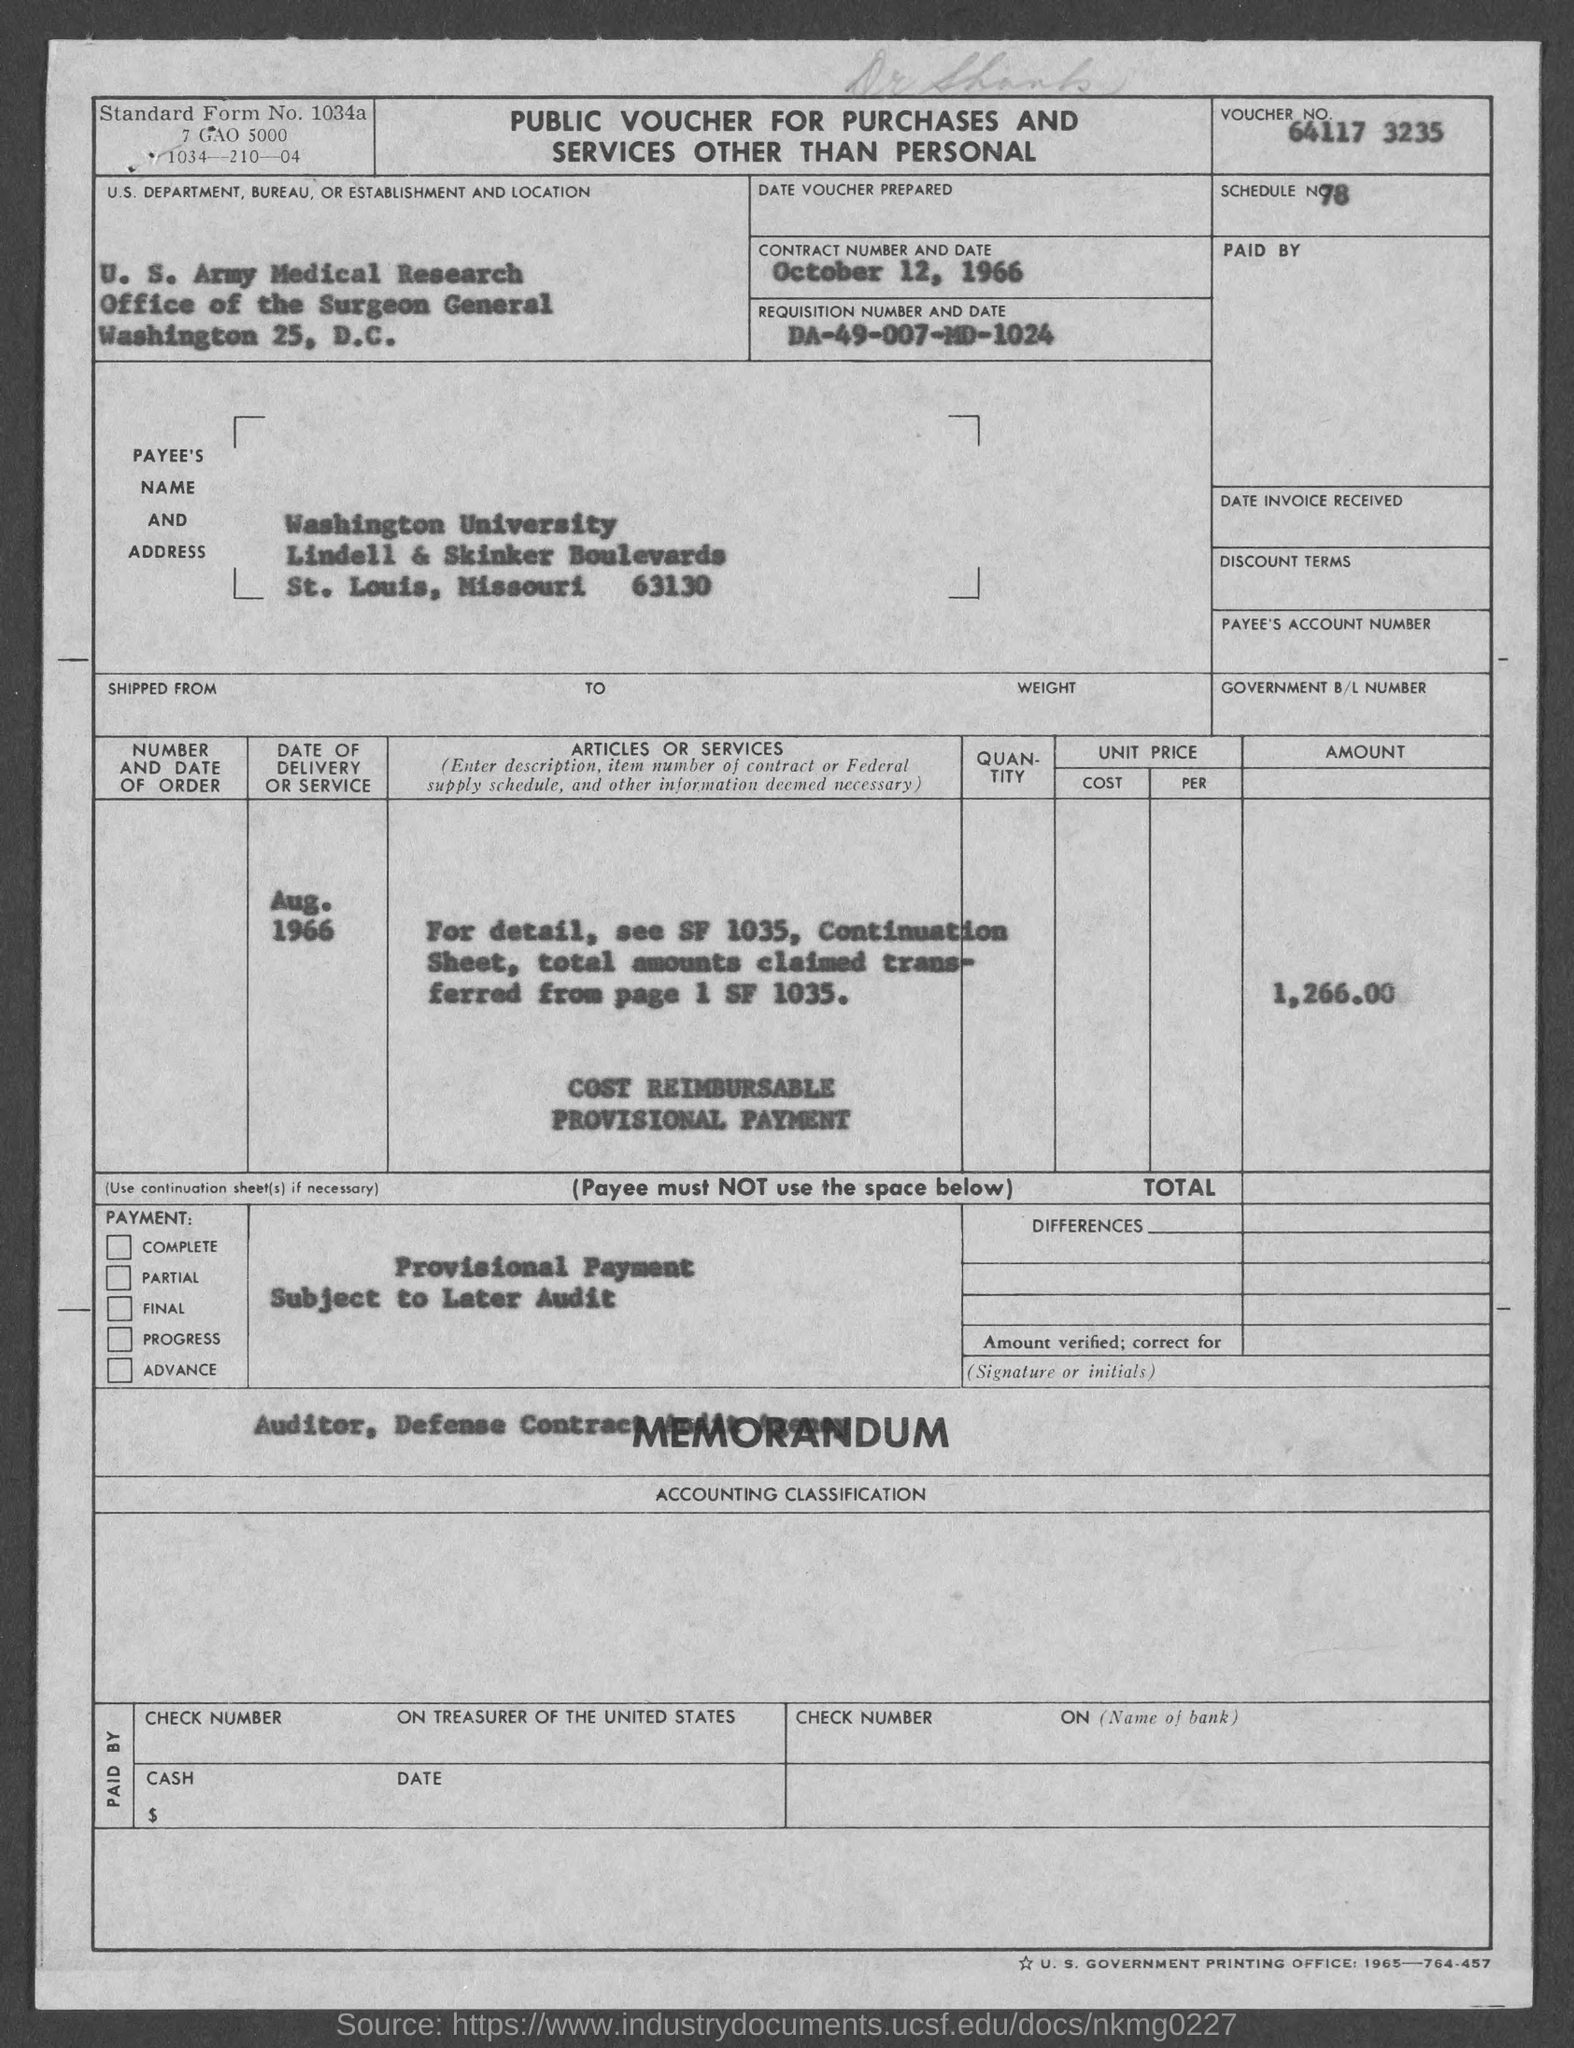Specify some key components in this picture. The location of Washington University in St. Louis, Missouri is known as Washington University. The requisition number is DA-49-007-MD-1024. The voucher number is 64117 3235... What is the standard form number? It is 1034a...". What is the schedule number?" the speaker asked, trailing off abruptly with an uncertain tone. 